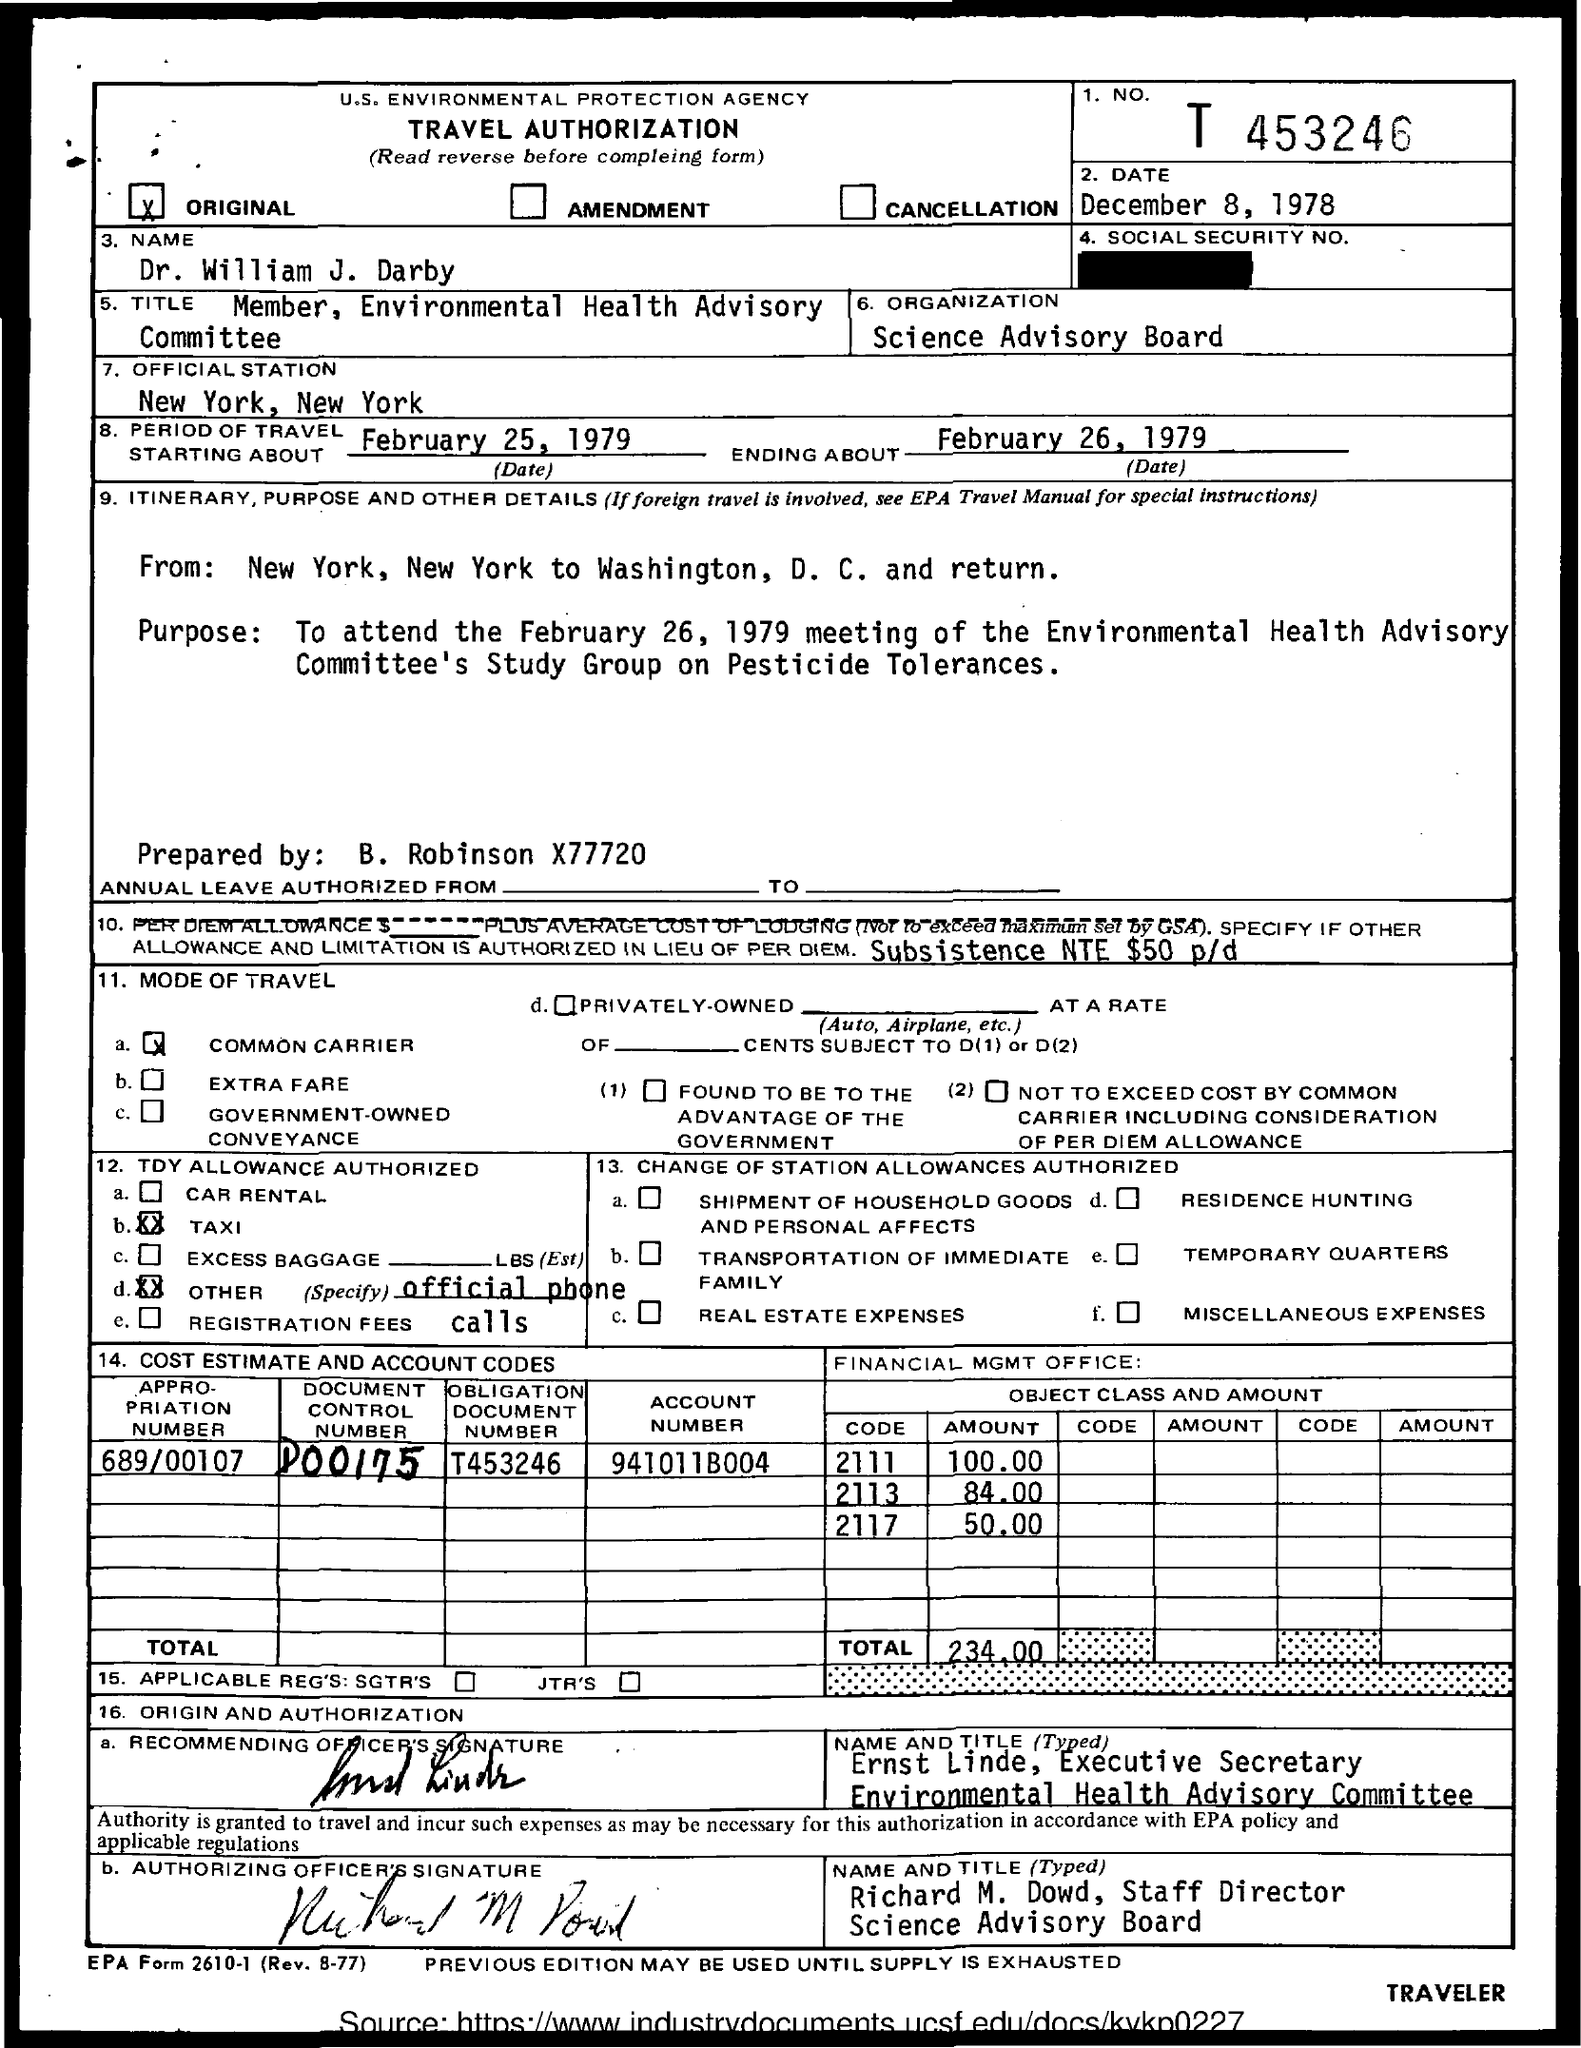Identify some key points in this picture. The name of the organization is the Science Advisory Board. The Appropriation Number is 689/00107. The Document Control Number is d00175... The total amount is 234.00. The destination is New York. 